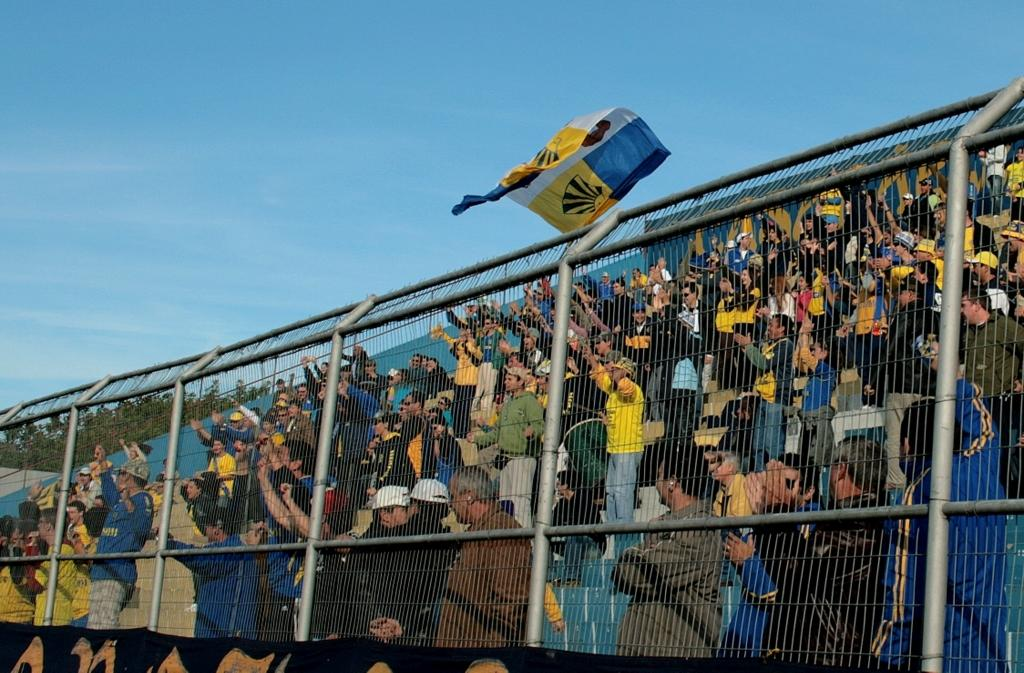What can be seen in the image? There are people standing in the image. How are the people dressed? The people are wearing different color dresses. What is the purpose of the net fencing in the image? The net fencing is not described in the facts, so we cannot determine its purpose. What is hanging in the image? There is a banner and a flag in the image. What type of natural elements are present in the image? There are trees and the sky in the image. What is the color of the sky in the image? The sky is blue and white in color. What type of polish is being applied to the achiever's shoes in the image? There is no mention of an achiever or shoes in the image, so we cannot determine if any polish is being applied. 